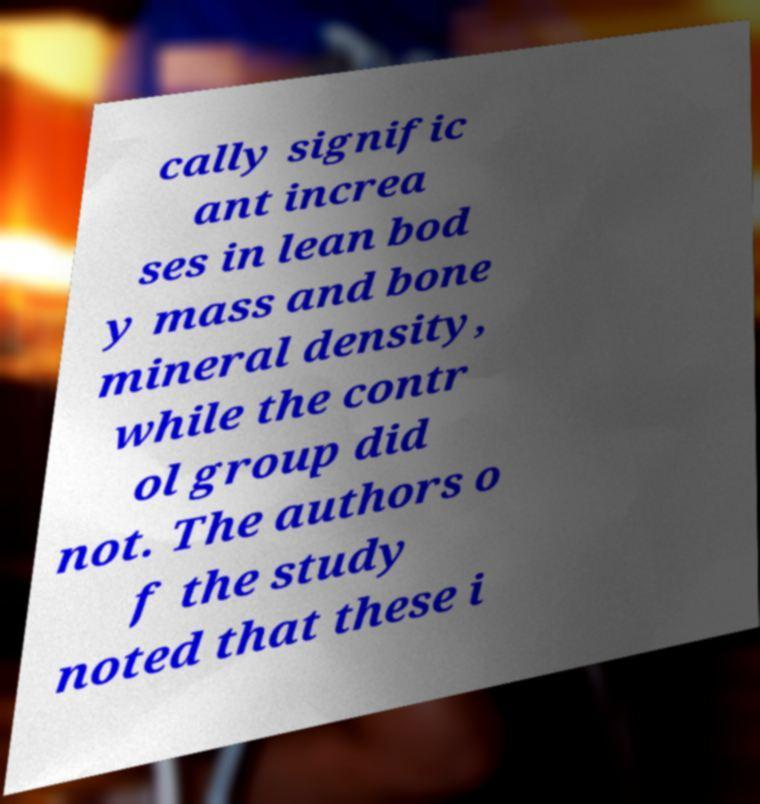There's text embedded in this image that I need extracted. Can you transcribe it verbatim? cally signific ant increa ses in lean bod y mass and bone mineral density, while the contr ol group did not. The authors o f the study noted that these i 